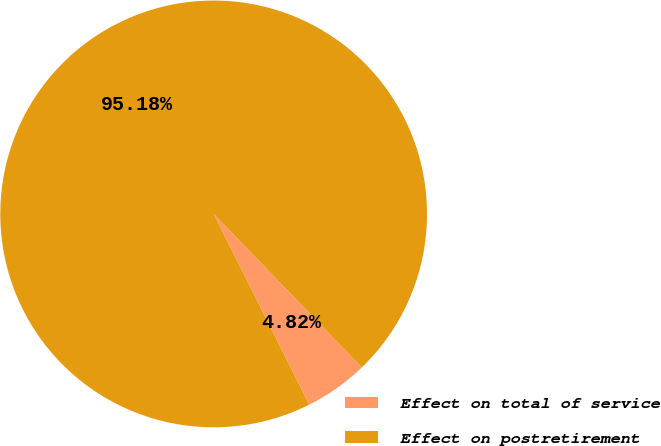Convert chart. <chart><loc_0><loc_0><loc_500><loc_500><pie_chart><fcel>Effect on total of service<fcel>Effect on postretirement<nl><fcel>4.82%<fcel>95.18%<nl></chart> 